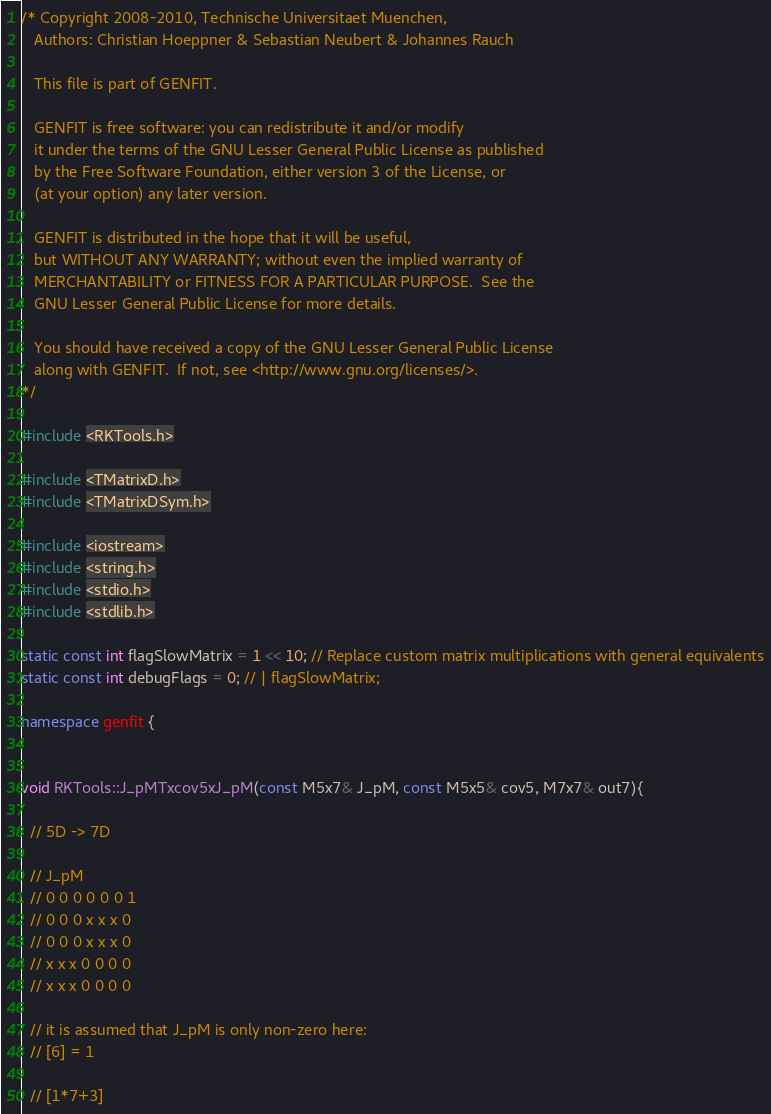Convert code to text. <code><loc_0><loc_0><loc_500><loc_500><_C++_>/* Copyright 2008-2010, Technische Universitaet Muenchen,
   Authors: Christian Hoeppner & Sebastian Neubert & Johannes Rauch

   This file is part of GENFIT.

   GENFIT is free software: you can redistribute it and/or modify
   it under the terms of the GNU Lesser General Public License as published
   by the Free Software Foundation, either version 3 of the License, or
   (at your option) any later version.

   GENFIT is distributed in the hope that it will be useful,
   but WITHOUT ANY WARRANTY; without even the implied warranty of
   MERCHANTABILITY or FITNESS FOR A PARTICULAR PURPOSE.  See the
   GNU Lesser General Public License for more details.

   You should have received a copy of the GNU Lesser General Public License
   along with GENFIT.  If not, see <http://www.gnu.org/licenses/>.
*/

#include <RKTools.h>

#include <TMatrixD.h>
#include <TMatrixDSym.h>

#include <iostream>
#include <string.h>
#include <stdio.h>
#include <stdlib.h>

static const int flagSlowMatrix = 1 << 10; // Replace custom matrix multiplications with general equivalents
static const int debugFlags = 0; // | flagSlowMatrix;

namespace genfit {


void RKTools::J_pMTxcov5xJ_pM(const M5x7& J_pM, const M5x5& cov5, M7x7& out7){

  // 5D -> 7D

  // J_pM
  // 0 0 0 0 0 0 1
  // 0 0 0 x x x 0
  // 0 0 0 x x x 0
  // x x x 0 0 0 0
  // x x x 0 0 0 0

  // it is assumed that J_pM is only non-zero here:
  // [6] = 1

  // [1*7+3]</code> 